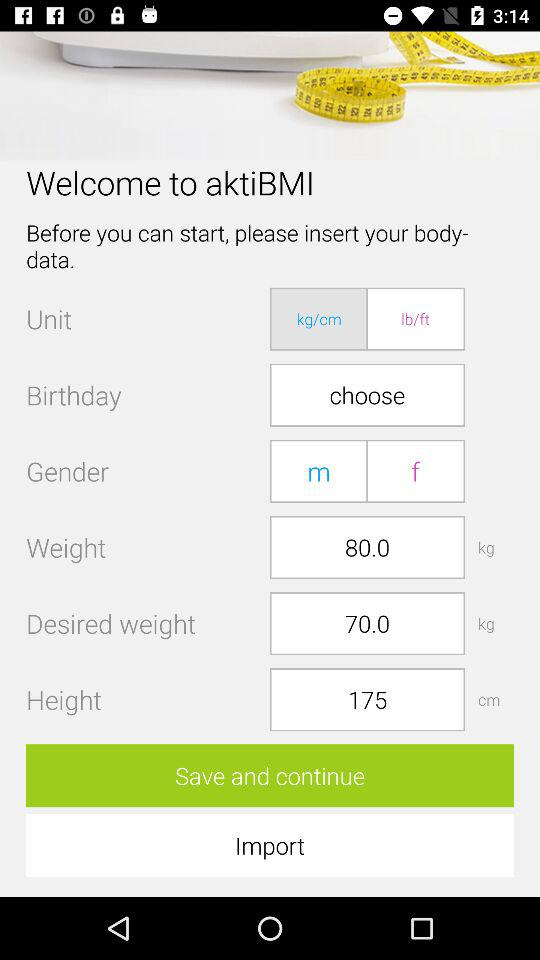What is the unit? The unit is kg/cm. 